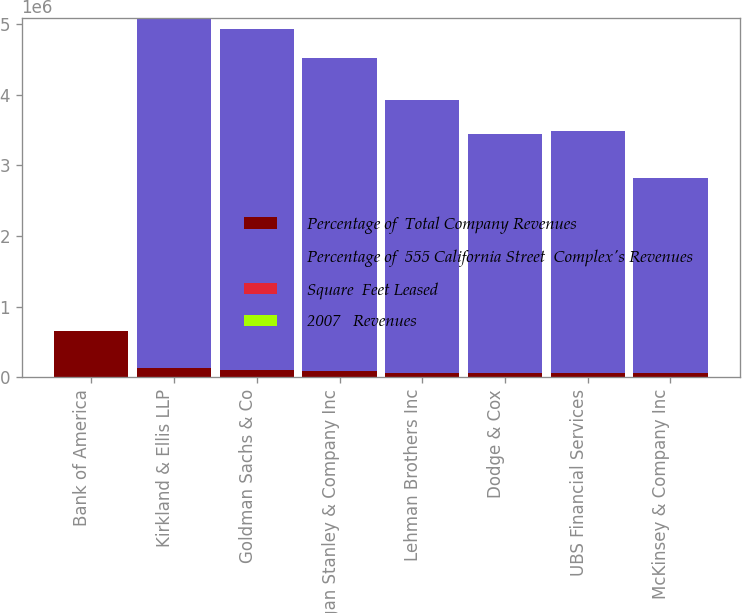Convert chart. <chart><loc_0><loc_0><loc_500><loc_500><stacked_bar_chart><ecel><fcel>Bank of America<fcel>Kirkland & Ellis LLP<fcel>Goldman Sachs & Co<fcel>Morgan Stanley & Company Inc<fcel>Lehman Brothers Inc<fcel>Dodge & Cox<fcel>UBS Financial Services<fcel>McKinsey & Company Inc<nl><fcel>Percentage of  Total Company Revenues<fcel>659000<fcel>125000<fcel>97000<fcel>89000<fcel>61000<fcel>62000<fcel>59000<fcel>54000<nl><fcel>Percentage of  555 California Street  Complex's Revenues<fcel>32.5<fcel>4.957e+06<fcel>4.835e+06<fcel>4.427e+06<fcel>3.861e+06<fcel>3.386e+06<fcel>3.425e+06<fcel>2.77e+06<nl><fcel>Square  Feet Leased<fcel>32.5<fcel>7.3<fcel>7.1<fcel>6.5<fcel>5.7<fcel>5<fcel>5<fcel>4.1<nl><fcel>2007   Revenues<fcel>0.7<fcel>0.2<fcel>0.1<fcel>0.1<fcel>0.1<fcel>0.1<fcel>0.1<fcel>0.1<nl></chart> 